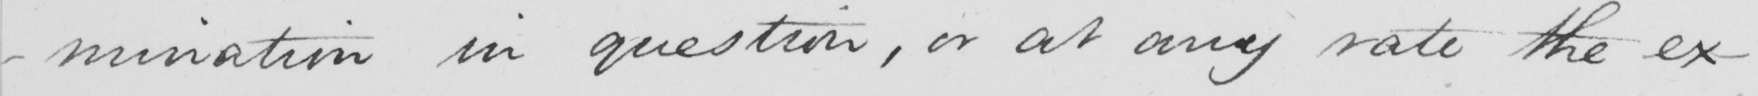Can you tell me what this handwritten text says? -mination in question , or at any rate the ex- 